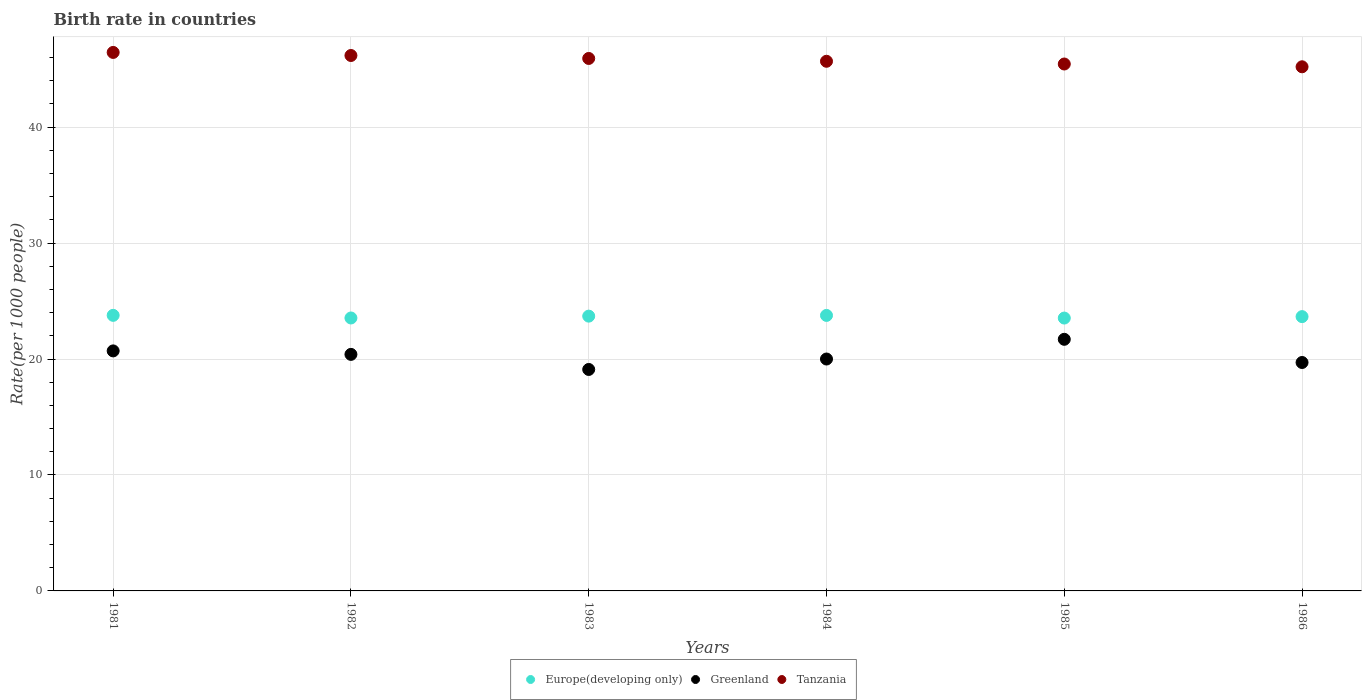What is the birth rate in Europe(developing only) in 1985?
Provide a succinct answer. 23.53. Across all years, what is the maximum birth rate in Greenland?
Make the answer very short. 21.7. Across all years, what is the minimum birth rate in Europe(developing only)?
Give a very brief answer. 23.53. In which year was the birth rate in Greenland minimum?
Give a very brief answer. 1983. What is the total birth rate in Tanzania in the graph?
Make the answer very short. 274.87. What is the difference between the birth rate in Europe(developing only) in 1985 and that in 1986?
Offer a very short reply. -0.12. What is the difference between the birth rate in Greenland in 1985 and the birth rate in Tanzania in 1982?
Your answer should be compact. -24.48. What is the average birth rate in Greenland per year?
Keep it short and to the point. 20.27. In the year 1985, what is the difference between the birth rate in Greenland and birth rate in Tanzania?
Your answer should be very brief. -23.74. What is the ratio of the birth rate in Greenland in 1983 to that in 1986?
Your answer should be very brief. 0.97. Is the birth rate in Greenland in 1981 less than that in 1983?
Ensure brevity in your answer.  No. Is the difference between the birth rate in Greenland in 1982 and 1983 greater than the difference between the birth rate in Tanzania in 1982 and 1983?
Ensure brevity in your answer.  Yes. What is the difference between the highest and the second highest birth rate in Europe(developing only)?
Your answer should be compact. 0.01. What is the difference between the highest and the lowest birth rate in Europe(developing only)?
Your answer should be very brief. 0.23. Is the sum of the birth rate in Greenland in 1983 and 1984 greater than the maximum birth rate in Tanzania across all years?
Make the answer very short. No. Is it the case that in every year, the sum of the birth rate in Greenland and birth rate in Tanzania  is greater than the birth rate in Europe(developing only)?
Keep it short and to the point. Yes. Does the birth rate in Europe(developing only) monotonically increase over the years?
Provide a succinct answer. No. How many years are there in the graph?
Provide a short and direct response. 6. Are the values on the major ticks of Y-axis written in scientific E-notation?
Your answer should be very brief. No. Does the graph contain any zero values?
Ensure brevity in your answer.  No. Does the graph contain grids?
Provide a succinct answer. Yes. How are the legend labels stacked?
Give a very brief answer. Horizontal. What is the title of the graph?
Make the answer very short. Birth rate in countries. What is the label or title of the Y-axis?
Give a very brief answer. Rate(per 1000 people). What is the Rate(per 1000 people) of Europe(developing only) in 1981?
Keep it short and to the point. 23.77. What is the Rate(per 1000 people) in Greenland in 1981?
Offer a terse response. 20.7. What is the Rate(per 1000 people) of Tanzania in 1981?
Give a very brief answer. 46.44. What is the Rate(per 1000 people) in Europe(developing only) in 1982?
Provide a short and direct response. 23.54. What is the Rate(per 1000 people) of Greenland in 1982?
Provide a succinct answer. 20.4. What is the Rate(per 1000 people) of Tanzania in 1982?
Offer a very short reply. 46.18. What is the Rate(per 1000 people) of Europe(developing only) in 1983?
Your answer should be compact. 23.7. What is the Rate(per 1000 people) of Tanzania in 1983?
Give a very brief answer. 45.92. What is the Rate(per 1000 people) of Europe(developing only) in 1984?
Offer a very short reply. 23.76. What is the Rate(per 1000 people) of Greenland in 1984?
Give a very brief answer. 20. What is the Rate(per 1000 people) of Tanzania in 1984?
Offer a very short reply. 45.68. What is the Rate(per 1000 people) of Europe(developing only) in 1985?
Provide a short and direct response. 23.53. What is the Rate(per 1000 people) in Greenland in 1985?
Your response must be concise. 21.7. What is the Rate(per 1000 people) in Tanzania in 1985?
Your response must be concise. 45.44. What is the Rate(per 1000 people) of Europe(developing only) in 1986?
Make the answer very short. 23.66. What is the Rate(per 1000 people) of Tanzania in 1986?
Keep it short and to the point. 45.2. Across all years, what is the maximum Rate(per 1000 people) of Europe(developing only)?
Keep it short and to the point. 23.77. Across all years, what is the maximum Rate(per 1000 people) of Greenland?
Offer a terse response. 21.7. Across all years, what is the maximum Rate(per 1000 people) in Tanzania?
Offer a terse response. 46.44. Across all years, what is the minimum Rate(per 1000 people) of Europe(developing only)?
Give a very brief answer. 23.53. Across all years, what is the minimum Rate(per 1000 people) of Greenland?
Ensure brevity in your answer.  19.1. Across all years, what is the minimum Rate(per 1000 people) of Tanzania?
Keep it short and to the point. 45.2. What is the total Rate(per 1000 people) of Europe(developing only) in the graph?
Give a very brief answer. 141.96. What is the total Rate(per 1000 people) in Greenland in the graph?
Your response must be concise. 121.6. What is the total Rate(per 1000 people) of Tanzania in the graph?
Your response must be concise. 274.87. What is the difference between the Rate(per 1000 people) in Europe(developing only) in 1981 and that in 1982?
Offer a terse response. 0.23. What is the difference between the Rate(per 1000 people) of Tanzania in 1981 and that in 1982?
Provide a short and direct response. 0.27. What is the difference between the Rate(per 1000 people) of Europe(developing only) in 1981 and that in 1983?
Provide a short and direct response. 0.07. What is the difference between the Rate(per 1000 people) of Greenland in 1981 and that in 1983?
Provide a short and direct response. 1.6. What is the difference between the Rate(per 1000 people) of Tanzania in 1981 and that in 1983?
Your answer should be compact. 0.52. What is the difference between the Rate(per 1000 people) of Europe(developing only) in 1981 and that in 1984?
Your response must be concise. 0.01. What is the difference between the Rate(per 1000 people) of Tanzania in 1981 and that in 1984?
Your response must be concise. 0.76. What is the difference between the Rate(per 1000 people) in Europe(developing only) in 1981 and that in 1985?
Keep it short and to the point. 0.23. What is the difference between the Rate(per 1000 people) of Greenland in 1981 and that in 1985?
Offer a terse response. -1. What is the difference between the Rate(per 1000 people) in Europe(developing only) in 1981 and that in 1986?
Your response must be concise. 0.11. What is the difference between the Rate(per 1000 people) in Tanzania in 1981 and that in 1986?
Your answer should be compact. 1.24. What is the difference between the Rate(per 1000 people) in Europe(developing only) in 1982 and that in 1983?
Give a very brief answer. -0.16. What is the difference between the Rate(per 1000 people) in Greenland in 1982 and that in 1983?
Your answer should be compact. 1.3. What is the difference between the Rate(per 1000 people) in Tanzania in 1982 and that in 1983?
Your answer should be very brief. 0.26. What is the difference between the Rate(per 1000 people) in Europe(developing only) in 1982 and that in 1984?
Your response must be concise. -0.22. What is the difference between the Rate(per 1000 people) in Greenland in 1982 and that in 1984?
Your answer should be very brief. 0.4. What is the difference between the Rate(per 1000 people) in Tanzania in 1982 and that in 1984?
Offer a very short reply. 0.5. What is the difference between the Rate(per 1000 people) in Europe(developing only) in 1982 and that in 1985?
Your answer should be compact. 0.01. What is the difference between the Rate(per 1000 people) of Tanzania in 1982 and that in 1985?
Provide a short and direct response. 0.73. What is the difference between the Rate(per 1000 people) of Europe(developing only) in 1982 and that in 1986?
Give a very brief answer. -0.12. What is the difference between the Rate(per 1000 people) of Greenland in 1982 and that in 1986?
Keep it short and to the point. 0.7. What is the difference between the Rate(per 1000 people) in Europe(developing only) in 1983 and that in 1984?
Offer a terse response. -0.06. What is the difference between the Rate(per 1000 people) in Tanzania in 1983 and that in 1984?
Your response must be concise. 0.24. What is the difference between the Rate(per 1000 people) in Europe(developing only) in 1983 and that in 1985?
Ensure brevity in your answer.  0.17. What is the difference between the Rate(per 1000 people) of Tanzania in 1983 and that in 1985?
Provide a succinct answer. 0.48. What is the difference between the Rate(per 1000 people) of Europe(developing only) in 1983 and that in 1986?
Ensure brevity in your answer.  0.04. What is the difference between the Rate(per 1000 people) of Greenland in 1983 and that in 1986?
Your response must be concise. -0.6. What is the difference between the Rate(per 1000 people) of Tanzania in 1983 and that in 1986?
Make the answer very short. 0.72. What is the difference between the Rate(per 1000 people) in Europe(developing only) in 1984 and that in 1985?
Your answer should be compact. 0.23. What is the difference between the Rate(per 1000 people) in Tanzania in 1984 and that in 1985?
Give a very brief answer. 0.24. What is the difference between the Rate(per 1000 people) in Europe(developing only) in 1984 and that in 1986?
Make the answer very short. 0.1. What is the difference between the Rate(per 1000 people) in Tanzania in 1984 and that in 1986?
Ensure brevity in your answer.  0.48. What is the difference between the Rate(per 1000 people) of Europe(developing only) in 1985 and that in 1986?
Give a very brief answer. -0.12. What is the difference between the Rate(per 1000 people) in Tanzania in 1985 and that in 1986?
Give a very brief answer. 0.24. What is the difference between the Rate(per 1000 people) of Europe(developing only) in 1981 and the Rate(per 1000 people) of Greenland in 1982?
Ensure brevity in your answer.  3.37. What is the difference between the Rate(per 1000 people) of Europe(developing only) in 1981 and the Rate(per 1000 people) of Tanzania in 1982?
Make the answer very short. -22.41. What is the difference between the Rate(per 1000 people) in Greenland in 1981 and the Rate(per 1000 people) in Tanzania in 1982?
Your response must be concise. -25.48. What is the difference between the Rate(per 1000 people) of Europe(developing only) in 1981 and the Rate(per 1000 people) of Greenland in 1983?
Give a very brief answer. 4.67. What is the difference between the Rate(per 1000 people) in Europe(developing only) in 1981 and the Rate(per 1000 people) in Tanzania in 1983?
Your answer should be compact. -22.16. What is the difference between the Rate(per 1000 people) of Greenland in 1981 and the Rate(per 1000 people) of Tanzania in 1983?
Provide a succinct answer. -25.22. What is the difference between the Rate(per 1000 people) in Europe(developing only) in 1981 and the Rate(per 1000 people) in Greenland in 1984?
Make the answer very short. 3.77. What is the difference between the Rate(per 1000 people) of Europe(developing only) in 1981 and the Rate(per 1000 people) of Tanzania in 1984?
Ensure brevity in your answer.  -21.91. What is the difference between the Rate(per 1000 people) of Greenland in 1981 and the Rate(per 1000 people) of Tanzania in 1984?
Ensure brevity in your answer.  -24.98. What is the difference between the Rate(per 1000 people) of Europe(developing only) in 1981 and the Rate(per 1000 people) of Greenland in 1985?
Your answer should be compact. 2.07. What is the difference between the Rate(per 1000 people) in Europe(developing only) in 1981 and the Rate(per 1000 people) in Tanzania in 1985?
Give a very brief answer. -21.68. What is the difference between the Rate(per 1000 people) in Greenland in 1981 and the Rate(per 1000 people) in Tanzania in 1985?
Your answer should be compact. -24.74. What is the difference between the Rate(per 1000 people) of Europe(developing only) in 1981 and the Rate(per 1000 people) of Greenland in 1986?
Offer a very short reply. 4.07. What is the difference between the Rate(per 1000 people) in Europe(developing only) in 1981 and the Rate(per 1000 people) in Tanzania in 1986?
Keep it short and to the point. -21.44. What is the difference between the Rate(per 1000 people) of Greenland in 1981 and the Rate(per 1000 people) of Tanzania in 1986?
Provide a short and direct response. -24.5. What is the difference between the Rate(per 1000 people) of Europe(developing only) in 1982 and the Rate(per 1000 people) of Greenland in 1983?
Your response must be concise. 4.44. What is the difference between the Rate(per 1000 people) of Europe(developing only) in 1982 and the Rate(per 1000 people) of Tanzania in 1983?
Your answer should be very brief. -22.38. What is the difference between the Rate(per 1000 people) of Greenland in 1982 and the Rate(per 1000 people) of Tanzania in 1983?
Your answer should be compact. -25.52. What is the difference between the Rate(per 1000 people) in Europe(developing only) in 1982 and the Rate(per 1000 people) in Greenland in 1984?
Your answer should be very brief. 3.54. What is the difference between the Rate(per 1000 people) of Europe(developing only) in 1982 and the Rate(per 1000 people) of Tanzania in 1984?
Provide a short and direct response. -22.14. What is the difference between the Rate(per 1000 people) of Greenland in 1982 and the Rate(per 1000 people) of Tanzania in 1984?
Keep it short and to the point. -25.28. What is the difference between the Rate(per 1000 people) of Europe(developing only) in 1982 and the Rate(per 1000 people) of Greenland in 1985?
Give a very brief answer. 1.84. What is the difference between the Rate(per 1000 people) in Europe(developing only) in 1982 and the Rate(per 1000 people) in Tanzania in 1985?
Make the answer very short. -21.9. What is the difference between the Rate(per 1000 people) of Greenland in 1982 and the Rate(per 1000 people) of Tanzania in 1985?
Provide a succinct answer. -25.04. What is the difference between the Rate(per 1000 people) of Europe(developing only) in 1982 and the Rate(per 1000 people) of Greenland in 1986?
Provide a short and direct response. 3.84. What is the difference between the Rate(per 1000 people) in Europe(developing only) in 1982 and the Rate(per 1000 people) in Tanzania in 1986?
Make the answer very short. -21.66. What is the difference between the Rate(per 1000 people) of Greenland in 1982 and the Rate(per 1000 people) of Tanzania in 1986?
Ensure brevity in your answer.  -24.8. What is the difference between the Rate(per 1000 people) of Europe(developing only) in 1983 and the Rate(per 1000 people) of Greenland in 1984?
Your response must be concise. 3.7. What is the difference between the Rate(per 1000 people) in Europe(developing only) in 1983 and the Rate(per 1000 people) in Tanzania in 1984?
Provide a succinct answer. -21.98. What is the difference between the Rate(per 1000 people) in Greenland in 1983 and the Rate(per 1000 people) in Tanzania in 1984?
Your answer should be compact. -26.58. What is the difference between the Rate(per 1000 people) in Europe(developing only) in 1983 and the Rate(per 1000 people) in Greenland in 1985?
Provide a short and direct response. 2. What is the difference between the Rate(per 1000 people) in Europe(developing only) in 1983 and the Rate(per 1000 people) in Tanzania in 1985?
Your response must be concise. -21.74. What is the difference between the Rate(per 1000 people) in Greenland in 1983 and the Rate(per 1000 people) in Tanzania in 1985?
Ensure brevity in your answer.  -26.34. What is the difference between the Rate(per 1000 people) of Europe(developing only) in 1983 and the Rate(per 1000 people) of Greenland in 1986?
Make the answer very short. 4. What is the difference between the Rate(per 1000 people) of Europe(developing only) in 1983 and the Rate(per 1000 people) of Tanzania in 1986?
Provide a short and direct response. -21.5. What is the difference between the Rate(per 1000 people) of Greenland in 1983 and the Rate(per 1000 people) of Tanzania in 1986?
Give a very brief answer. -26.1. What is the difference between the Rate(per 1000 people) in Europe(developing only) in 1984 and the Rate(per 1000 people) in Greenland in 1985?
Provide a short and direct response. 2.06. What is the difference between the Rate(per 1000 people) of Europe(developing only) in 1984 and the Rate(per 1000 people) of Tanzania in 1985?
Provide a succinct answer. -21.68. What is the difference between the Rate(per 1000 people) of Greenland in 1984 and the Rate(per 1000 people) of Tanzania in 1985?
Offer a terse response. -25.44. What is the difference between the Rate(per 1000 people) in Europe(developing only) in 1984 and the Rate(per 1000 people) in Greenland in 1986?
Provide a succinct answer. 4.06. What is the difference between the Rate(per 1000 people) in Europe(developing only) in 1984 and the Rate(per 1000 people) in Tanzania in 1986?
Offer a very short reply. -21.44. What is the difference between the Rate(per 1000 people) in Greenland in 1984 and the Rate(per 1000 people) in Tanzania in 1986?
Provide a short and direct response. -25.2. What is the difference between the Rate(per 1000 people) in Europe(developing only) in 1985 and the Rate(per 1000 people) in Greenland in 1986?
Offer a terse response. 3.83. What is the difference between the Rate(per 1000 people) of Europe(developing only) in 1985 and the Rate(per 1000 people) of Tanzania in 1986?
Provide a succinct answer. -21.67. What is the difference between the Rate(per 1000 people) of Greenland in 1985 and the Rate(per 1000 people) of Tanzania in 1986?
Offer a terse response. -23.5. What is the average Rate(per 1000 people) of Europe(developing only) per year?
Provide a succinct answer. 23.66. What is the average Rate(per 1000 people) of Greenland per year?
Keep it short and to the point. 20.27. What is the average Rate(per 1000 people) of Tanzania per year?
Your answer should be very brief. 45.81. In the year 1981, what is the difference between the Rate(per 1000 people) in Europe(developing only) and Rate(per 1000 people) in Greenland?
Make the answer very short. 3.07. In the year 1981, what is the difference between the Rate(per 1000 people) in Europe(developing only) and Rate(per 1000 people) in Tanzania?
Make the answer very short. -22.68. In the year 1981, what is the difference between the Rate(per 1000 people) of Greenland and Rate(per 1000 people) of Tanzania?
Provide a succinct answer. -25.74. In the year 1982, what is the difference between the Rate(per 1000 people) of Europe(developing only) and Rate(per 1000 people) of Greenland?
Make the answer very short. 3.14. In the year 1982, what is the difference between the Rate(per 1000 people) of Europe(developing only) and Rate(per 1000 people) of Tanzania?
Provide a succinct answer. -22.64. In the year 1982, what is the difference between the Rate(per 1000 people) of Greenland and Rate(per 1000 people) of Tanzania?
Offer a terse response. -25.78. In the year 1983, what is the difference between the Rate(per 1000 people) in Europe(developing only) and Rate(per 1000 people) in Greenland?
Offer a terse response. 4.6. In the year 1983, what is the difference between the Rate(per 1000 people) of Europe(developing only) and Rate(per 1000 people) of Tanzania?
Offer a terse response. -22.22. In the year 1983, what is the difference between the Rate(per 1000 people) in Greenland and Rate(per 1000 people) in Tanzania?
Your answer should be very brief. -26.82. In the year 1984, what is the difference between the Rate(per 1000 people) in Europe(developing only) and Rate(per 1000 people) in Greenland?
Provide a short and direct response. 3.76. In the year 1984, what is the difference between the Rate(per 1000 people) in Europe(developing only) and Rate(per 1000 people) in Tanzania?
Give a very brief answer. -21.92. In the year 1984, what is the difference between the Rate(per 1000 people) of Greenland and Rate(per 1000 people) of Tanzania?
Offer a very short reply. -25.68. In the year 1985, what is the difference between the Rate(per 1000 people) of Europe(developing only) and Rate(per 1000 people) of Greenland?
Offer a very short reply. 1.83. In the year 1985, what is the difference between the Rate(per 1000 people) in Europe(developing only) and Rate(per 1000 people) in Tanzania?
Offer a terse response. -21.91. In the year 1985, what is the difference between the Rate(per 1000 people) in Greenland and Rate(per 1000 people) in Tanzania?
Provide a short and direct response. -23.74. In the year 1986, what is the difference between the Rate(per 1000 people) in Europe(developing only) and Rate(per 1000 people) in Greenland?
Offer a very short reply. 3.96. In the year 1986, what is the difference between the Rate(per 1000 people) in Europe(developing only) and Rate(per 1000 people) in Tanzania?
Keep it short and to the point. -21.55. In the year 1986, what is the difference between the Rate(per 1000 people) of Greenland and Rate(per 1000 people) of Tanzania?
Your answer should be compact. -25.5. What is the ratio of the Rate(per 1000 people) in Europe(developing only) in 1981 to that in 1982?
Your answer should be very brief. 1.01. What is the ratio of the Rate(per 1000 people) in Greenland in 1981 to that in 1982?
Keep it short and to the point. 1.01. What is the ratio of the Rate(per 1000 people) of Europe(developing only) in 1981 to that in 1983?
Ensure brevity in your answer.  1. What is the ratio of the Rate(per 1000 people) of Greenland in 1981 to that in 1983?
Give a very brief answer. 1.08. What is the ratio of the Rate(per 1000 people) of Tanzania in 1981 to that in 1983?
Offer a terse response. 1.01. What is the ratio of the Rate(per 1000 people) in Europe(developing only) in 1981 to that in 1984?
Keep it short and to the point. 1. What is the ratio of the Rate(per 1000 people) of Greenland in 1981 to that in 1984?
Give a very brief answer. 1.03. What is the ratio of the Rate(per 1000 people) in Tanzania in 1981 to that in 1984?
Your answer should be very brief. 1.02. What is the ratio of the Rate(per 1000 people) in Europe(developing only) in 1981 to that in 1985?
Ensure brevity in your answer.  1.01. What is the ratio of the Rate(per 1000 people) in Greenland in 1981 to that in 1985?
Offer a very short reply. 0.95. What is the ratio of the Rate(per 1000 people) of Tanzania in 1981 to that in 1985?
Make the answer very short. 1.02. What is the ratio of the Rate(per 1000 people) in Greenland in 1981 to that in 1986?
Provide a short and direct response. 1.05. What is the ratio of the Rate(per 1000 people) of Tanzania in 1981 to that in 1986?
Make the answer very short. 1.03. What is the ratio of the Rate(per 1000 people) of Europe(developing only) in 1982 to that in 1983?
Your answer should be compact. 0.99. What is the ratio of the Rate(per 1000 people) in Greenland in 1982 to that in 1983?
Ensure brevity in your answer.  1.07. What is the ratio of the Rate(per 1000 people) of Tanzania in 1982 to that in 1983?
Offer a terse response. 1.01. What is the ratio of the Rate(per 1000 people) in Tanzania in 1982 to that in 1984?
Offer a terse response. 1.01. What is the ratio of the Rate(per 1000 people) in Europe(developing only) in 1982 to that in 1985?
Provide a short and direct response. 1. What is the ratio of the Rate(per 1000 people) in Greenland in 1982 to that in 1985?
Offer a terse response. 0.94. What is the ratio of the Rate(per 1000 people) in Tanzania in 1982 to that in 1985?
Your response must be concise. 1.02. What is the ratio of the Rate(per 1000 people) of Europe(developing only) in 1982 to that in 1986?
Ensure brevity in your answer.  1. What is the ratio of the Rate(per 1000 people) of Greenland in 1982 to that in 1986?
Provide a succinct answer. 1.04. What is the ratio of the Rate(per 1000 people) of Tanzania in 1982 to that in 1986?
Make the answer very short. 1.02. What is the ratio of the Rate(per 1000 people) in Europe(developing only) in 1983 to that in 1984?
Provide a succinct answer. 1. What is the ratio of the Rate(per 1000 people) of Greenland in 1983 to that in 1984?
Your answer should be compact. 0.95. What is the ratio of the Rate(per 1000 people) of Tanzania in 1983 to that in 1984?
Offer a terse response. 1.01. What is the ratio of the Rate(per 1000 people) of Europe(developing only) in 1983 to that in 1985?
Ensure brevity in your answer.  1.01. What is the ratio of the Rate(per 1000 people) in Greenland in 1983 to that in 1985?
Your answer should be very brief. 0.88. What is the ratio of the Rate(per 1000 people) of Tanzania in 1983 to that in 1985?
Give a very brief answer. 1.01. What is the ratio of the Rate(per 1000 people) in Greenland in 1983 to that in 1986?
Keep it short and to the point. 0.97. What is the ratio of the Rate(per 1000 people) of Tanzania in 1983 to that in 1986?
Your response must be concise. 1.02. What is the ratio of the Rate(per 1000 people) of Europe(developing only) in 1984 to that in 1985?
Your response must be concise. 1.01. What is the ratio of the Rate(per 1000 people) of Greenland in 1984 to that in 1985?
Provide a short and direct response. 0.92. What is the ratio of the Rate(per 1000 people) of Tanzania in 1984 to that in 1985?
Your answer should be very brief. 1.01. What is the ratio of the Rate(per 1000 people) of Greenland in 1984 to that in 1986?
Make the answer very short. 1.02. What is the ratio of the Rate(per 1000 people) of Tanzania in 1984 to that in 1986?
Keep it short and to the point. 1.01. What is the ratio of the Rate(per 1000 people) in Greenland in 1985 to that in 1986?
Provide a short and direct response. 1.1. What is the difference between the highest and the second highest Rate(per 1000 people) in Europe(developing only)?
Keep it short and to the point. 0.01. What is the difference between the highest and the second highest Rate(per 1000 people) in Greenland?
Give a very brief answer. 1. What is the difference between the highest and the second highest Rate(per 1000 people) in Tanzania?
Provide a succinct answer. 0.27. What is the difference between the highest and the lowest Rate(per 1000 people) of Europe(developing only)?
Give a very brief answer. 0.23. What is the difference between the highest and the lowest Rate(per 1000 people) in Tanzania?
Your response must be concise. 1.24. 